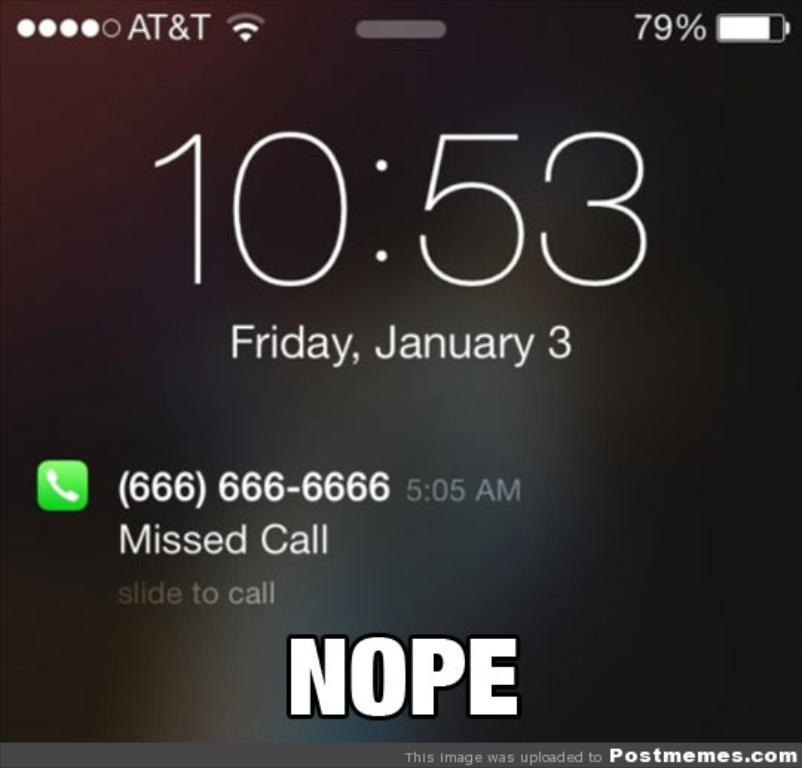<image>
Present a compact description of the photo's key features. 10:53 written on a phone on January 3rd 